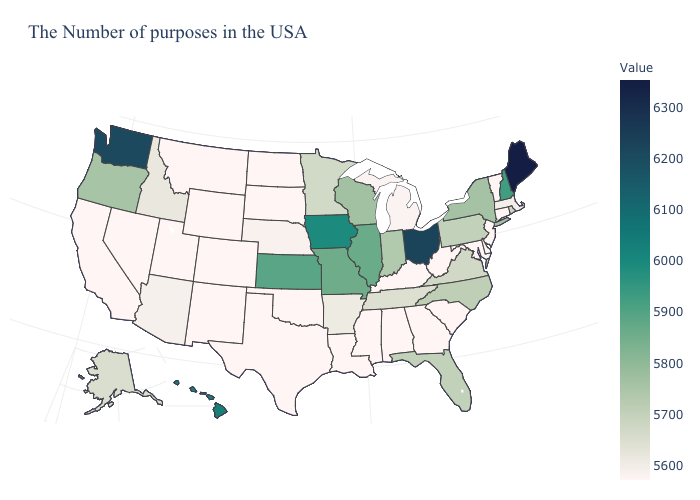Which states have the lowest value in the West?
Keep it brief. Wyoming, Colorado, New Mexico, Utah, Montana, Nevada, California. Which states hav the highest value in the Northeast?
Concise answer only. Maine. Does Ohio have the highest value in the MidWest?
Concise answer only. Yes. Which states have the lowest value in the USA?
Write a very short answer. Vermont, Connecticut, New Jersey, Delaware, Maryland, South Carolina, West Virginia, Georgia, Kentucky, Alabama, Mississippi, Louisiana, Oklahoma, Texas, South Dakota, North Dakota, Wyoming, Colorado, New Mexico, Utah, Montana, Nevada, California. Among the states that border South Carolina , which have the lowest value?
Give a very brief answer. Georgia. Is the legend a continuous bar?
Write a very short answer. Yes. 